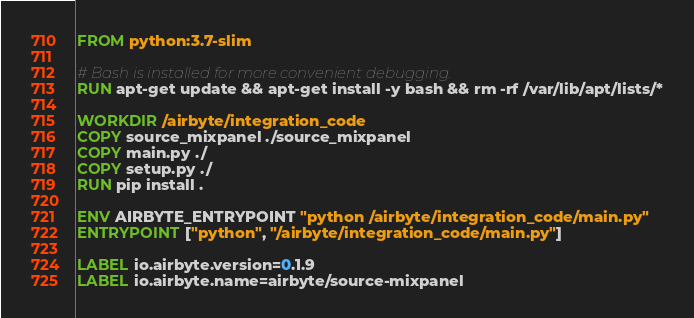Convert code to text. <code><loc_0><loc_0><loc_500><loc_500><_Dockerfile_>FROM python:3.7-slim

# Bash is installed for more convenient debugging.
RUN apt-get update && apt-get install -y bash && rm -rf /var/lib/apt/lists/*

WORKDIR /airbyte/integration_code
COPY source_mixpanel ./source_mixpanel
COPY main.py ./
COPY setup.py ./
RUN pip install .

ENV AIRBYTE_ENTRYPOINT "python /airbyte/integration_code/main.py"
ENTRYPOINT ["python", "/airbyte/integration_code/main.py"]

LABEL io.airbyte.version=0.1.9
LABEL io.airbyte.name=airbyte/source-mixpanel
</code> 